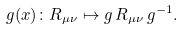Convert formula to latex. <formula><loc_0><loc_0><loc_500><loc_500>g ( x ) \colon R _ { \mu \nu } \mapsto g \, R _ { \mu \nu } \, g ^ { - 1 } .</formula> 